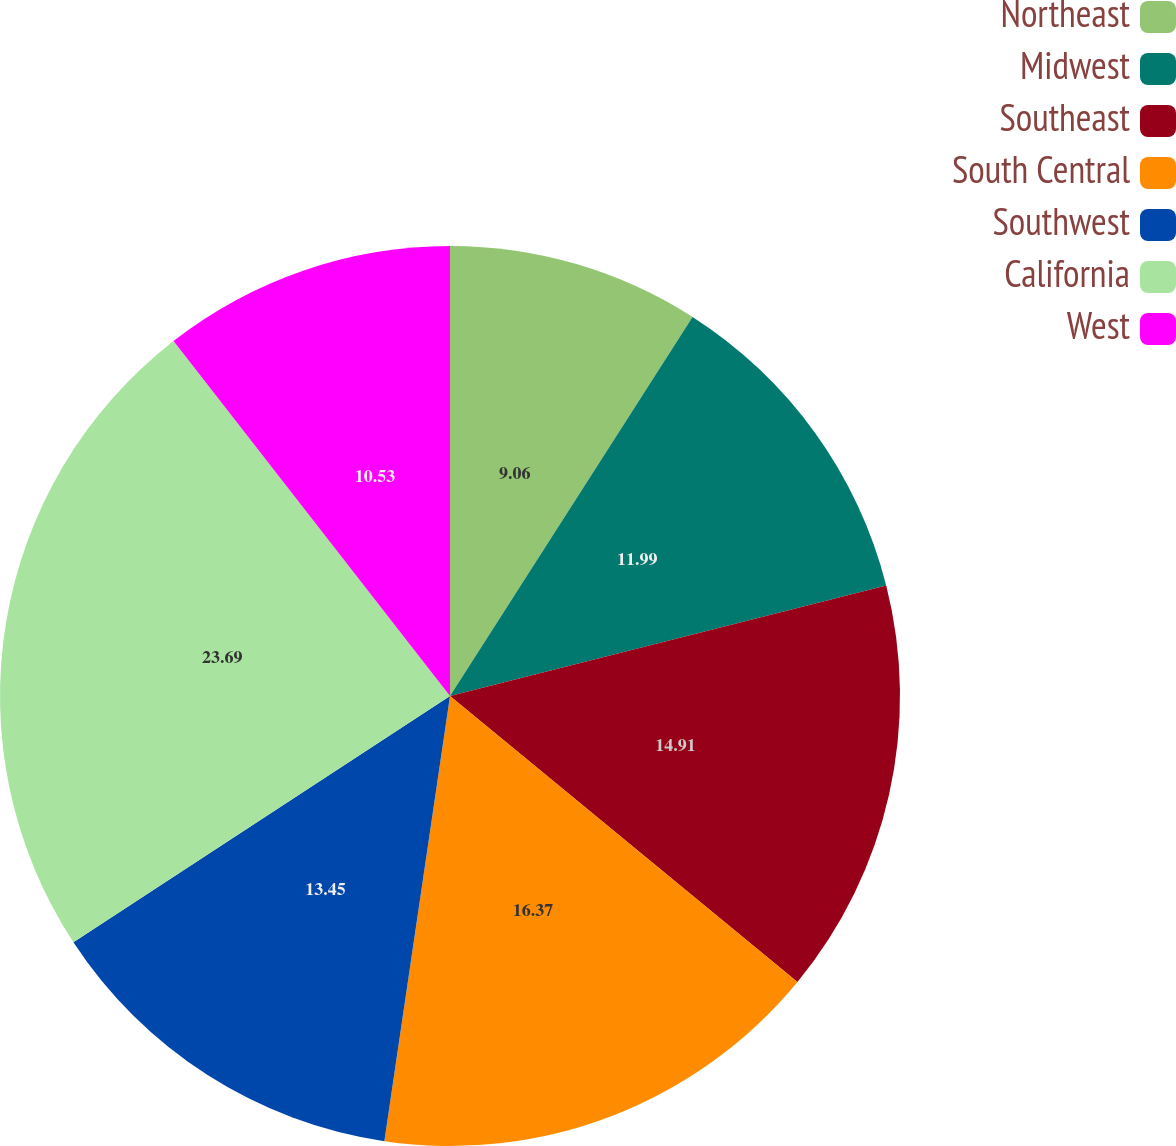<chart> <loc_0><loc_0><loc_500><loc_500><pie_chart><fcel>Northeast<fcel>Midwest<fcel>Southeast<fcel>South Central<fcel>Southwest<fcel>California<fcel>West<nl><fcel>9.06%<fcel>11.99%<fcel>14.91%<fcel>16.37%<fcel>13.45%<fcel>23.69%<fcel>10.53%<nl></chart> 